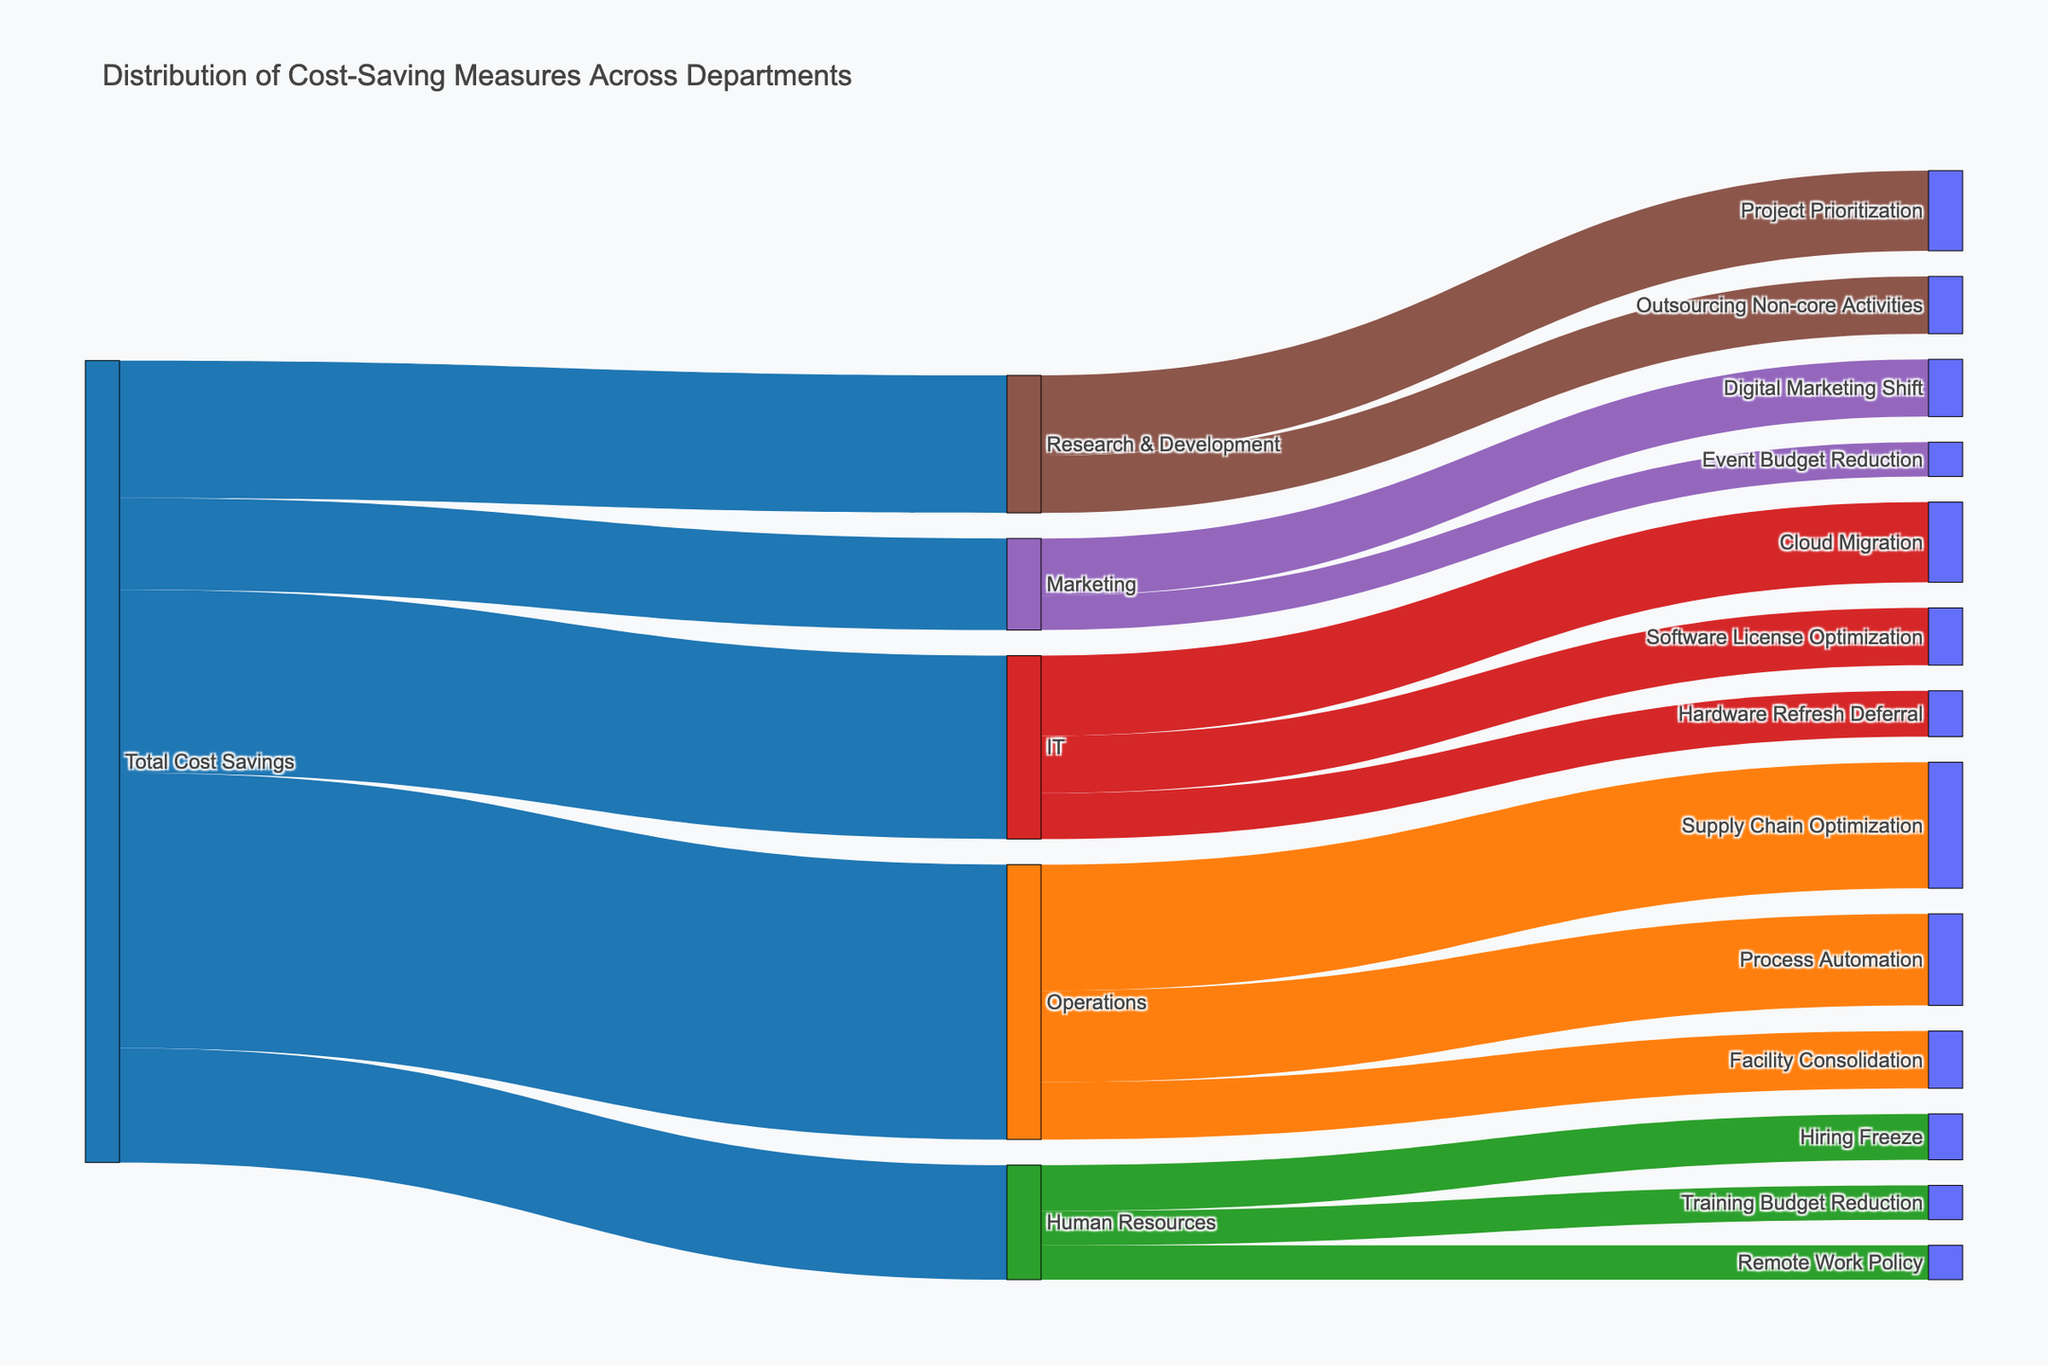What is the total cost savings in the IT department? The Sankey diagram shows IT department savings flowing from "Total Cost Savings" to "IT," with a value of 8,000,000 displayed for this connection.
Answer: 8,000,000 Which cost-saving measure in the Operations department saved the most money? The Sankey diagram highlights the "Operations" flows into three measures, with "Supply Chain Optimization" having the highest value of 5,500,000.
Answer: Supply Chain Optimization How much total cost savings were achieved by the Operations department? The values for cost-saving measures in the Operations department ("Supply Chain Optimization," "Process Automation," and "Facility Consolidation") add up to 5,500,000 + 4,000,000 + 2,500,000 = 12,000,000.
Answer: 12,000,000 Which department had the least total savings? The "Total Cost Savings" flows split into five departments, with "Marketing" having the smallest value of 4,000,000.
Answer: Marketing Compare the savings from "Cloud Migration" in IT with "Project Prioritization" in Research & Development. Which is higher, and by how much? "Cloud Migration" has a value of 3,500,000, and "Project Prioritization" has 3,500,000. Since both have the same value, there is no difference.
Answer: No difference What is the second largest cost-saving measure in Human Resources? The Sankey diagram shows cost-saving measures in the Human Resources department, where "Hiring Freeze" is 2,000,000, "Remote Work Policy" is 1,500,000, and "Training Budget Reduction" is 1,500,000. The second largest is "Remote Work Policy," tied with "Training Budget Reduction."
Answer: Remote Work Policy and Training Budget Reduction Total cost savings from IT, Marketing, and Research & Development add up to what amount? Summing up values: IT (8,000,000), Marketing (4,000,000), and Research & Development (6,000,000), the total is 8,000,000 + 4,000,000 + 6,000,000 = 18,000,000.
Answer: 18,000,000 How does the value of the "Digital Marketing Shift" in Marketing compare to the "Software License Optimization" in IT? "Digital Marketing Shift" in Marketing has a value of 2,500,000, and "Software License Optimization" in IT also has 2,500,000. They have equal values.
Answer: Equal Explain the cost-saving measures in Human Resources in terms of percentage of total Human Resources savings. For Human Resources, the measures have values: "Hiring Freeze" (2,000,000), "Remote Work Policy" (1,500,000), and "Training Budget Reduction" (1,500,000). The total is 5,000,000. The percentage is calculated as the measure value over total: Hiring Freeze (2,000,000 / 5,000,000 * 100) = 40%, Remote Work Policy (1,500,000 / 5,000,000 * 100) = 30%, and Training Budget Reduction (1,500,000 / 5,000,000 * 100) = 30%.
Answer: Hiring Freeze: 40%, Remote Work Policy: 30%, Training Budget Reduction: 30% 